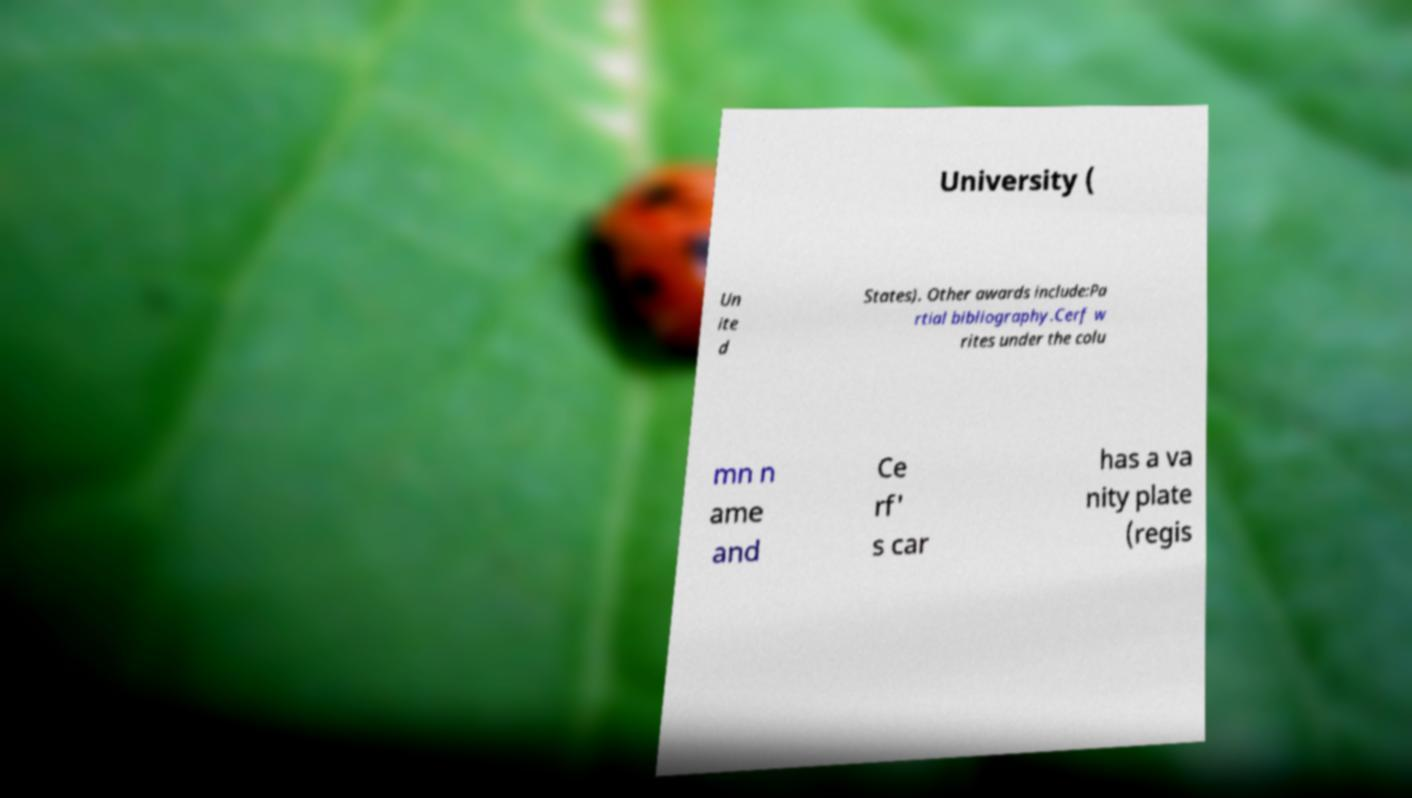Can you accurately transcribe the text from the provided image for me? University ( Un ite d States). Other awards include:Pa rtial bibliography.Cerf w rites under the colu mn n ame and Ce rf' s car has a va nity plate (regis 